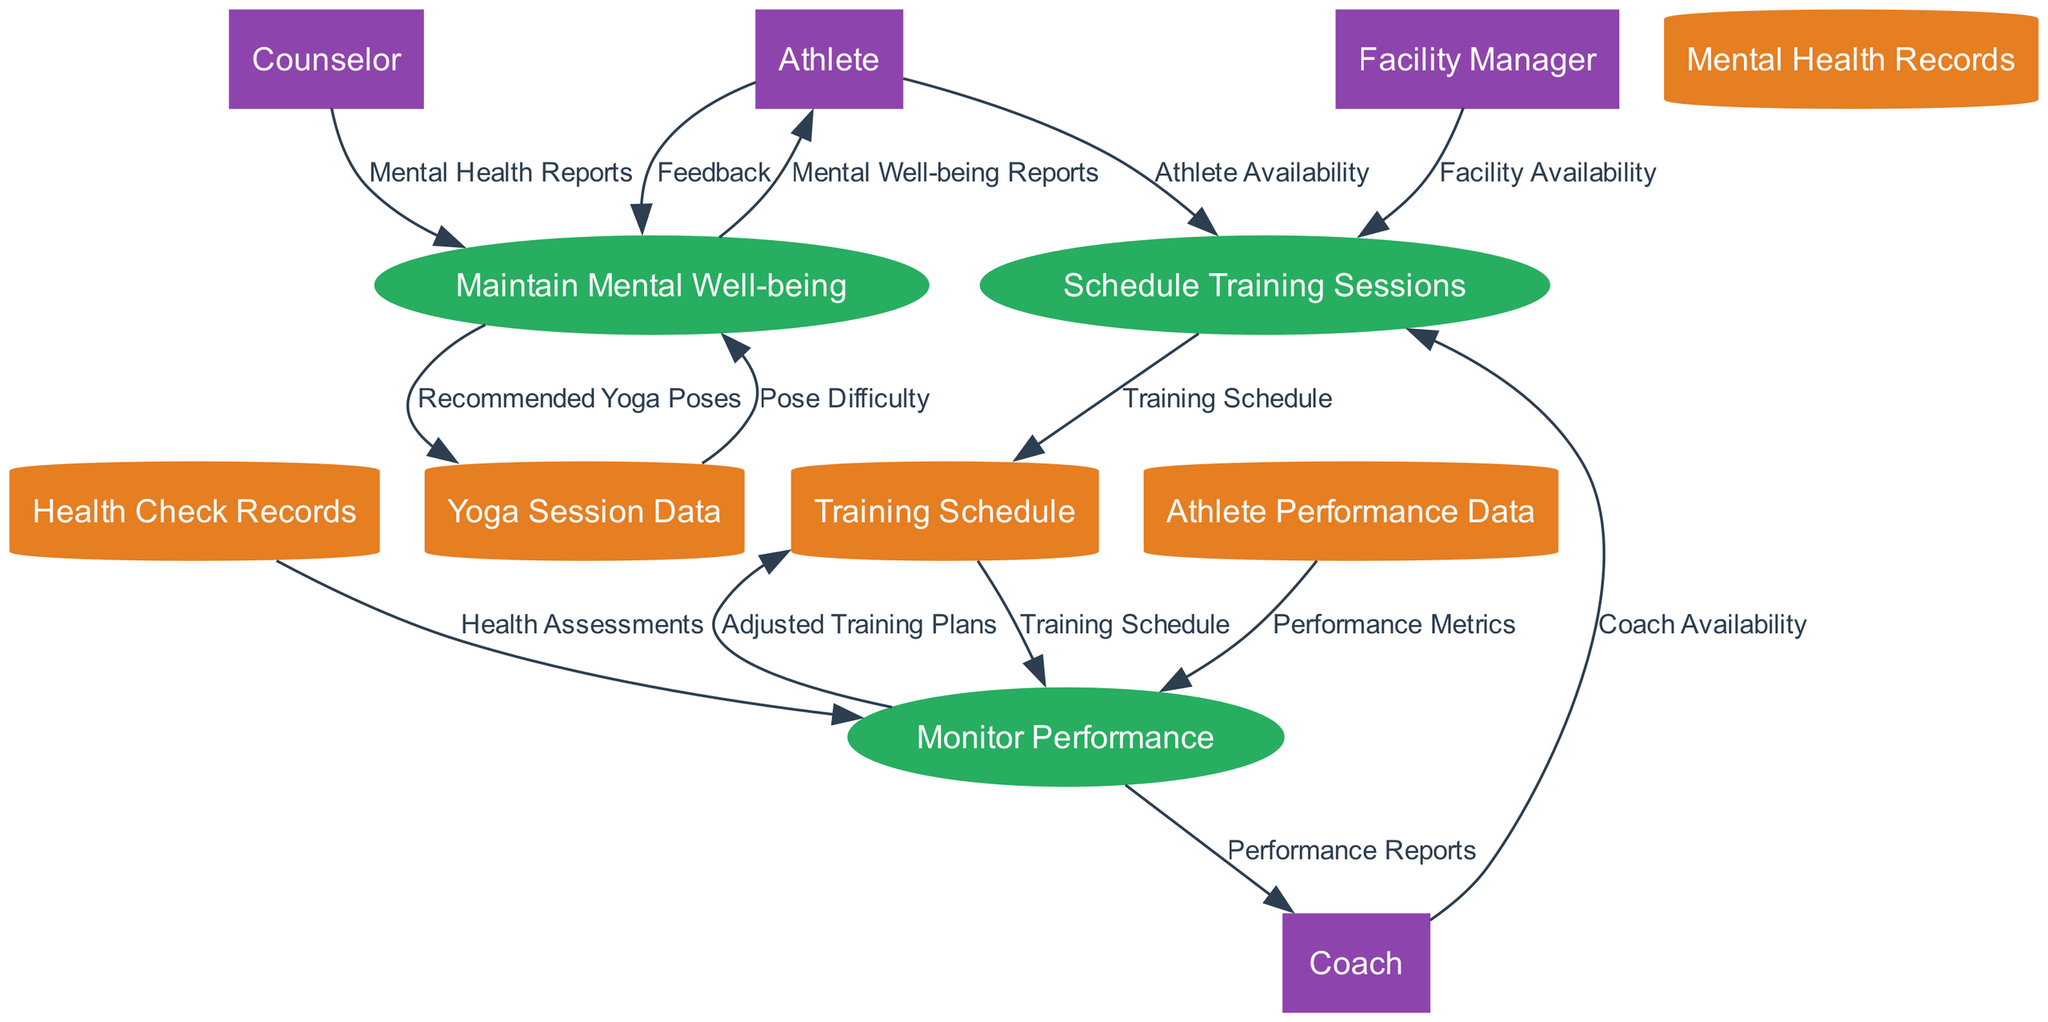What are the inputs for scheduling training sessions? The inputs for scheduling training sessions, as shown in the diagram, are "Athlete Availability," "Coach Availability," and "Facility Availability." These inputs are necessary to create a comprehensive training schedule that accommodates all parties involved.
Answer: Athlete Availability, Coach Availability, Facility Availability What is the output of the "Monitor Performance" process? The output of the "Monitor Performance" process includes two main components: "Performance Reports" and "Adjusted Training Plans." This indicates that monitoring performance results in both an assessment of athlete performance and modifications to their training regimen.
Answer: Performance Reports, Adjusted Training Plans How many external entities are involved in the diagram? By reviewing the diagram, we see that there are four identified external entities: "Athlete," "Coach," "Facility Manager," and "Counselor." This highlights the collaborative nature of the training process and the roles these individuals play.
Answer: 4 Which data store is directly affected by the "Maintain Mental Well-being" process? The "Maintain Mental Well-being" process affects the "Yoga Session Data" data store, resulting in the output of "Recommended Yoga Poses." This shows that the mental well-being process draws directly from data related to yoga sessions.
Answer: Yoga Session Data What is the sequence of processes involved after "Schedule Training Sessions"? After "Schedule Training Sessions," the next process is "Monitor Performance." This indicates that once the training schedule is set, the focus shifts to evaluating the performance of athletes during those scheduled sessions.
Answer: Monitor Performance How does an athlete contribute to both performance monitoring and mental well-being? An athlete contributes to performance monitoring by providing "Feedback," which is crucial for assessing how well the training schedule is working. Simultaneously, they also provide feedback to the "Maintain Mental Well-being" process, indicating their mental state. This highlights the athlete's active role in both areas.
Answer: Feedback What type of data does the "Health Check Records" data store contain? The "Health Check Records" data store contains "Injury Reports" and "Health Assessments," which provide critical information regarding an athlete's physical condition and any injuries that might affect their training.
Answer: Injury Reports, Health Assessments 